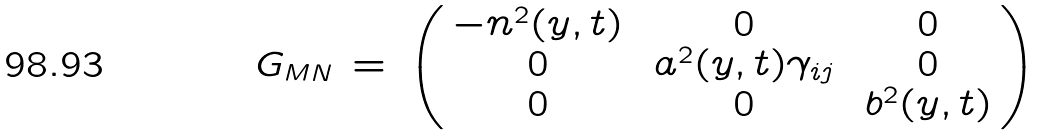Convert formula to latex. <formula><loc_0><loc_0><loc_500><loc_500>G _ { M N } \, = \, \left ( \begin{array} { c c c } - n ^ { 2 } ( y , t ) \, & \, 0 \, & \, 0 \\ 0 \, & \, a ^ { 2 } ( y , t ) \gamma _ { i j } \, & \, 0 \\ 0 \, & \, 0 \, & \, b ^ { 2 } ( y , t ) \end{array} \right ) \,</formula> 